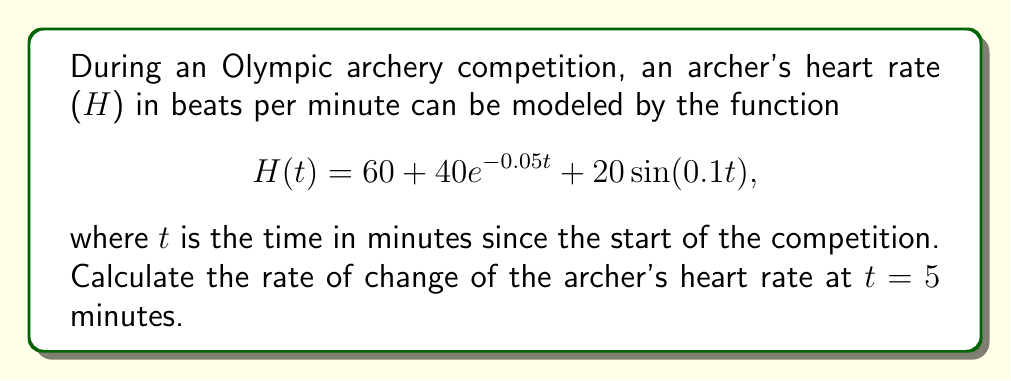Solve this math problem. To find the rate of change of the archer's heart rate at t = 5 minutes, we need to calculate the derivative of the given function H(t) and then evaluate it at t = 5.

1. Let's start by finding the derivative of H(t):

   $H(t) = 60 + 40e^{-0.05t} + 20\sin(0.1t)$

   Using the sum rule and chain rule of differentiation:

   $H'(t) = 0 + 40(-0.05)e^{-0.05t} + 20(0.1)\cos(0.1t)$

   $H'(t) = -2e^{-0.05t} + 2\cos(0.1t)$

2. Now, we need to evaluate H'(t) at t = 5:

   $H'(5) = -2e^{-0.05(5)} + 2\cos(0.1(5))$

3. Let's calculate each part:

   $e^{-0.05(5)} = e^{-0.25} \approx 0.7788$

   $\cos(0.1(5)) = \cos(0.5) \approx 0.8776$

4. Substituting these values:

   $H'(5) = -2(0.7788) + 2(0.8776)$
   
   $H'(5) = -1.5576 + 1.7552$
   
   $H'(5) = 0.1976$

The rate of change is measured in beats per minute per minute, or simply beats per minute squared (bpm²).
Answer: The rate of change of the archer's heart rate at t = 5 minutes is approximately 0.1976 bpm². 